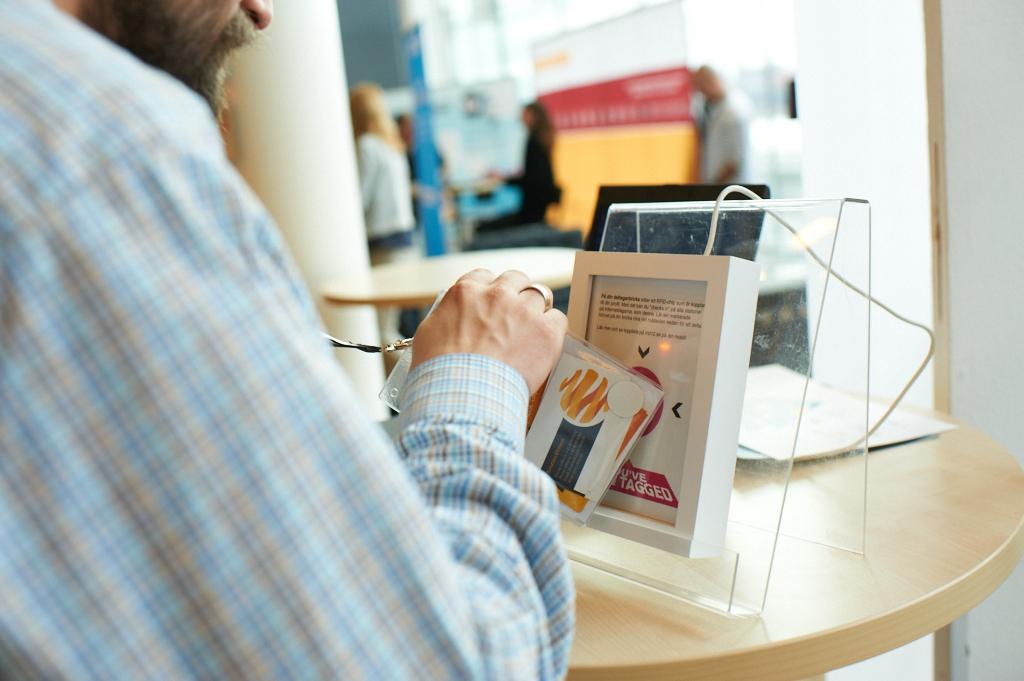Could you give a brief overview of what you see in this image? In this image I see a man who is holding a id card and there is an electronic equipment on this table and I see few papers. In the background I see few people who are blurred. 